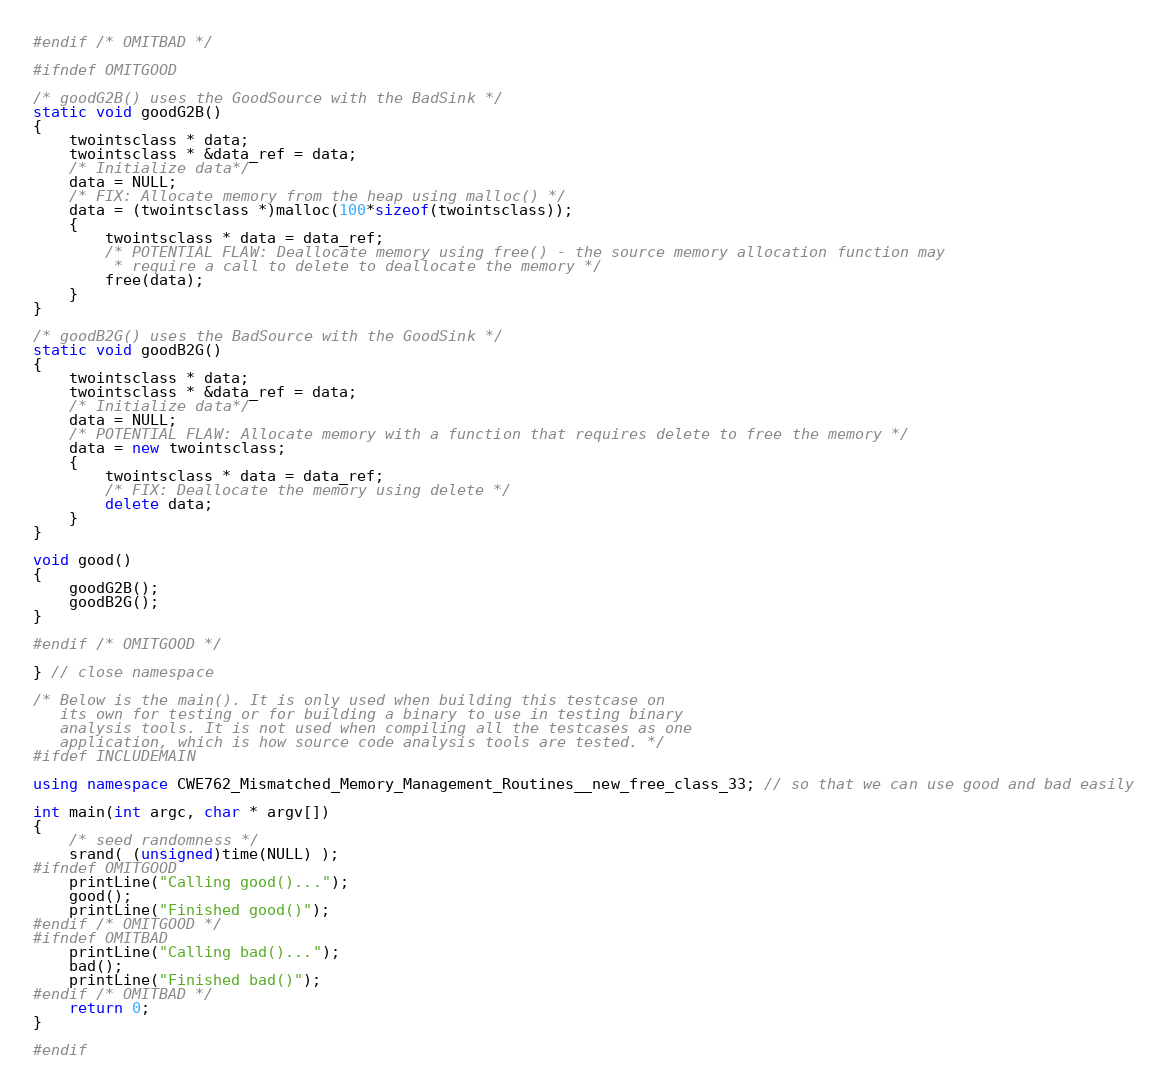Convert code to text. <code><loc_0><loc_0><loc_500><loc_500><_C++_>
#endif /* OMITBAD */

#ifndef OMITGOOD

/* goodG2B() uses the GoodSource with the BadSink */
static void goodG2B()
{
    twointsclass * data;
    twointsclass * &data_ref = data;
    /* Initialize data*/
    data = NULL;
    /* FIX: Allocate memory from the heap using malloc() */
    data = (twointsclass *)malloc(100*sizeof(twointsclass));
    {
        twointsclass * data = data_ref;
        /* POTENTIAL FLAW: Deallocate memory using free() - the source memory allocation function may
         * require a call to delete to deallocate the memory */
        free(data);
    }
}

/* goodB2G() uses the BadSource with the GoodSink */
static void goodB2G()
{
    twointsclass * data;
    twointsclass * &data_ref = data;
    /* Initialize data*/
    data = NULL;
    /* POTENTIAL FLAW: Allocate memory with a function that requires delete to free the memory */
    data = new twointsclass;
    {
        twointsclass * data = data_ref;
        /* FIX: Deallocate the memory using delete */
        delete data;
    }
}

void good()
{
    goodG2B();
    goodB2G();
}

#endif /* OMITGOOD */

} // close namespace

/* Below is the main(). It is only used when building this testcase on
   its own for testing or for building a binary to use in testing binary
   analysis tools. It is not used when compiling all the testcases as one
   application, which is how source code analysis tools are tested. */
#ifdef INCLUDEMAIN

using namespace CWE762_Mismatched_Memory_Management_Routines__new_free_class_33; // so that we can use good and bad easily

int main(int argc, char * argv[])
{
    /* seed randomness */
    srand( (unsigned)time(NULL) );
#ifndef OMITGOOD
    printLine("Calling good()...");
    good();
    printLine("Finished good()");
#endif /* OMITGOOD */
#ifndef OMITBAD
    printLine("Calling bad()...");
    bad();
    printLine("Finished bad()");
#endif /* OMITBAD */
    return 0;
}

#endif
</code> 